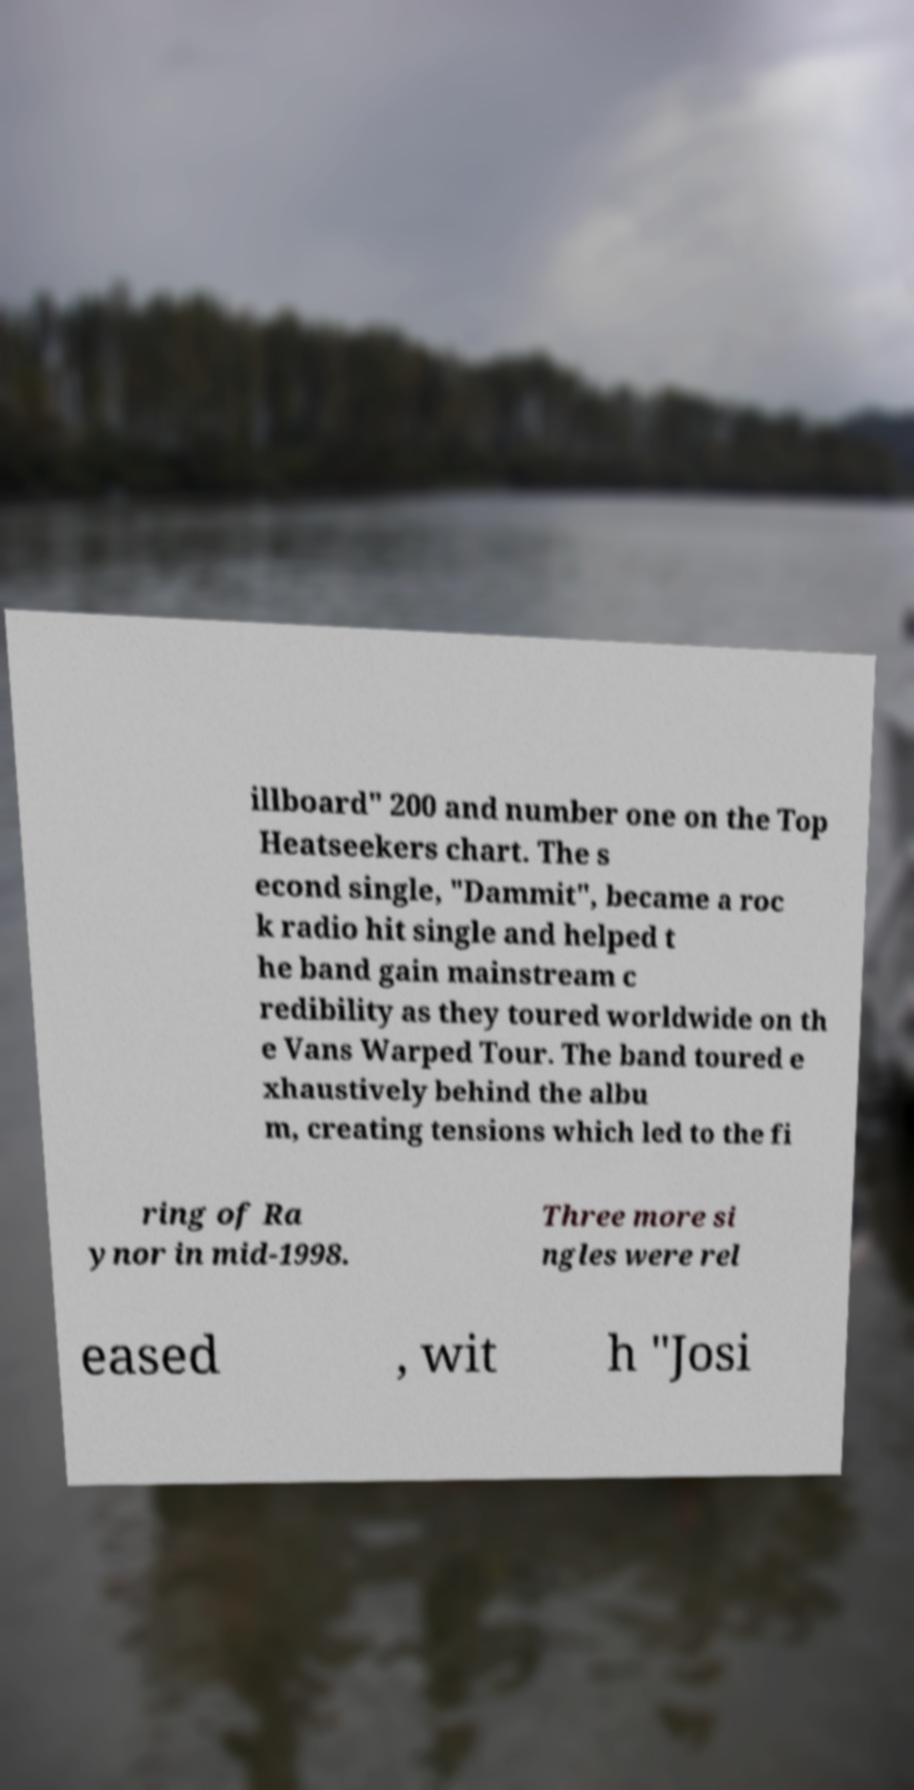Please read and relay the text visible in this image. What does it say? illboard" 200 and number one on the Top Heatseekers chart. The s econd single, "Dammit", became a roc k radio hit single and helped t he band gain mainstream c redibility as they toured worldwide on th e Vans Warped Tour. The band toured e xhaustively behind the albu m, creating tensions which led to the fi ring of Ra ynor in mid-1998. Three more si ngles were rel eased , wit h "Josi 